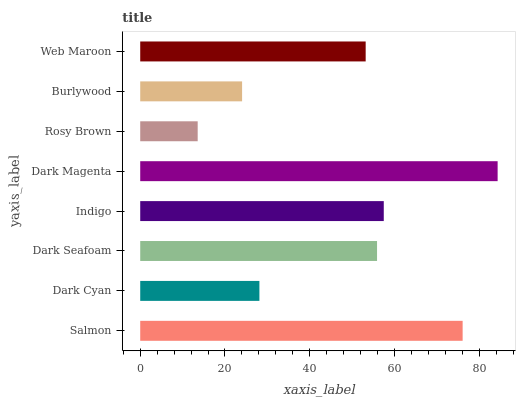Is Rosy Brown the minimum?
Answer yes or no. Yes. Is Dark Magenta the maximum?
Answer yes or no. Yes. Is Dark Cyan the minimum?
Answer yes or no. No. Is Dark Cyan the maximum?
Answer yes or no. No. Is Salmon greater than Dark Cyan?
Answer yes or no. Yes. Is Dark Cyan less than Salmon?
Answer yes or no. Yes. Is Dark Cyan greater than Salmon?
Answer yes or no. No. Is Salmon less than Dark Cyan?
Answer yes or no. No. Is Dark Seafoam the high median?
Answer yes or no. Yes. Is Web Maroon the low median?
Answer yes or no. Yes. Is Web Maroon the high median?
Answer yes or no. No. Is Dark Cyan the low median?
Answer yes or no. No. 